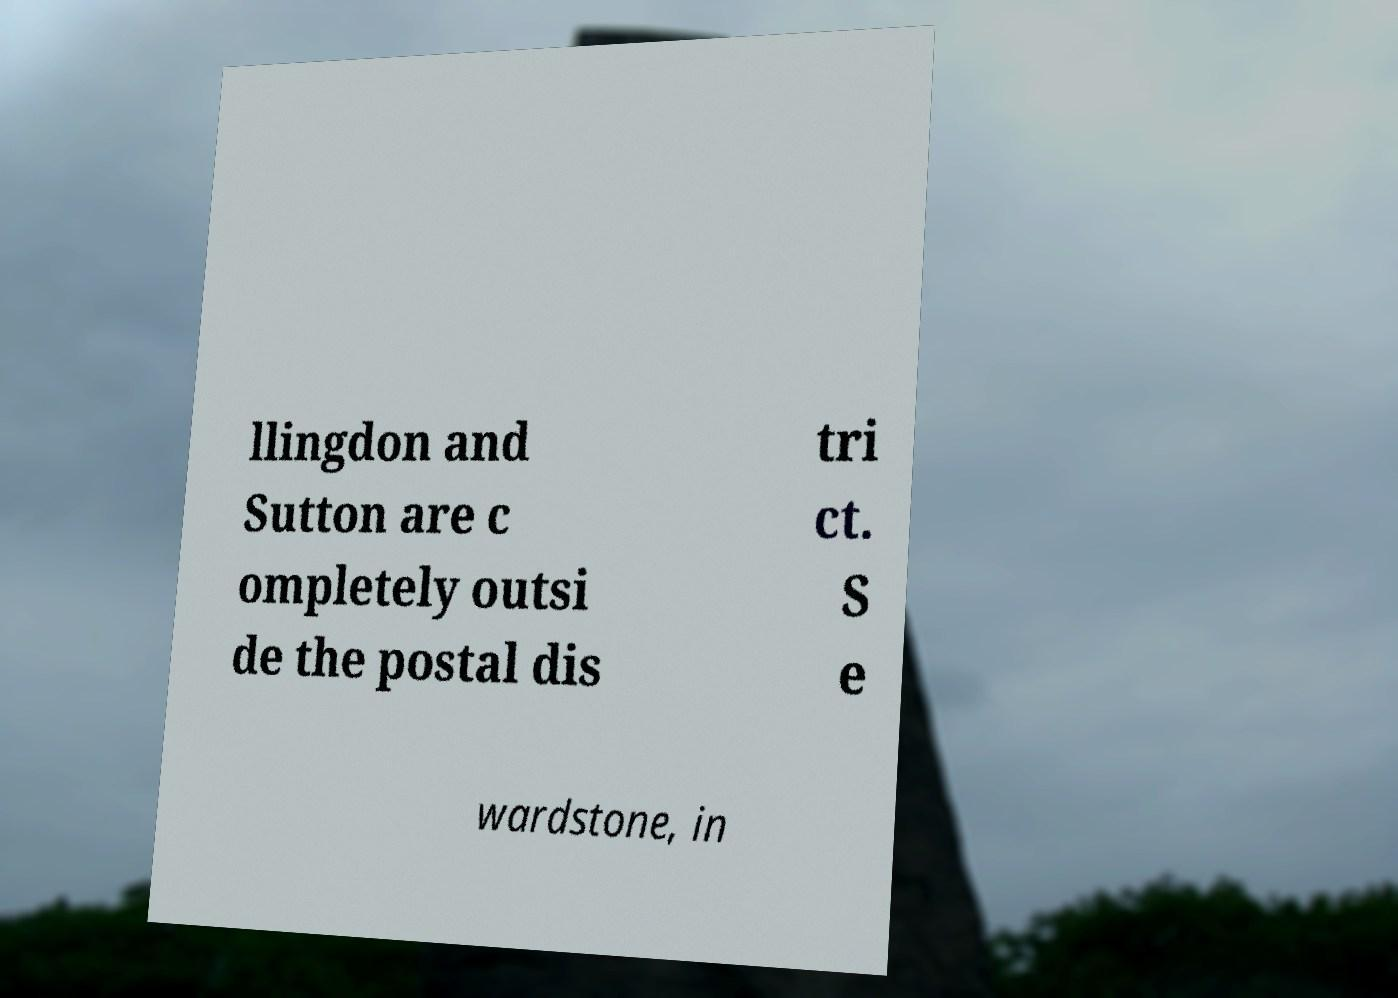Can you read and provide the text displayed in the image?This photo seems to have some interesting text. Can you extract and type it out for me? llingdon and Sutton are c ompletely outsi de the postal dis tri ct. S e wardstone, in 